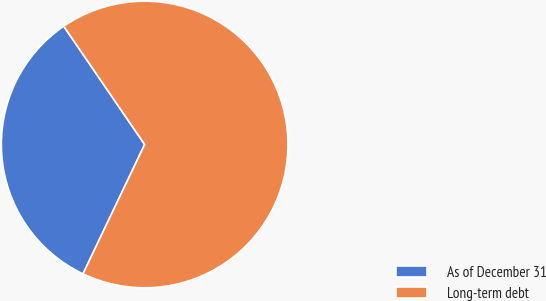<chart> <loc_0><loc_0><loc_500><loc_500><pie_chart><fcel>As of December 31<fcel>Long-term debt<nl><fcel>33.37%<fcel>66.63%<nl></chart> 